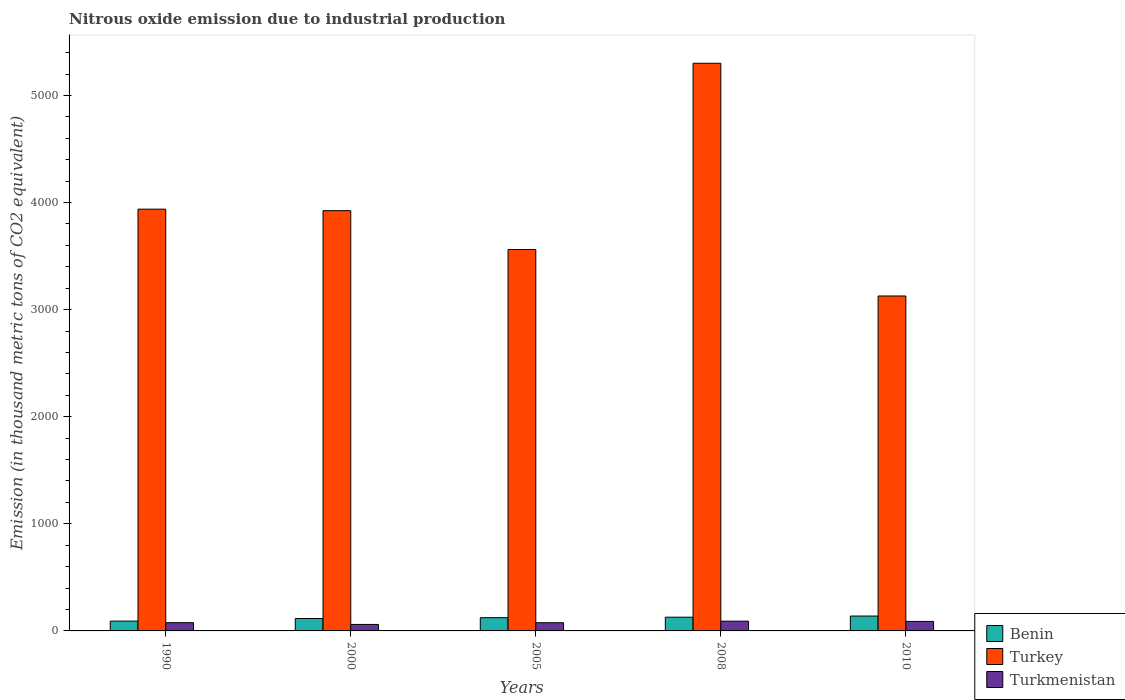How many different coloured bars are there?
Your response must be concise. 3. How many groups of bars are there?
Provide a succinct answer. 5. How many bars are there on the 5th tick from the left?
Make the answer very short. 3. How many bars are there on the 4th tick from the right?
Your answer should be compact. 3. What is the label of the 4th group of bars from the left?
Offer a terse response. 2008. What is the amount of nitrous oxide emitted in Turkey in 2008?
Give a very brief answer. 5300.3. Across all years, what is the maximum amount of nitrous oxide emitted in Benin?
Offer a very short reply. 139. Across all years, what is the minimum amount of nitrous oxide emitted in Turkmenistan?
Give a very brief answer. 60.5. What is the total amount of nitrous oxide emitted in Turkmenistan in the graph?
Your response must be concise. 393.9. What is the difference between the amount of nitrous oxide emitted in Benin in 1990 and that in 2005?
Give a very brief answer. -31.9. What is the average amount of nitrous oxide emitted in Turkmenistan per year?
Keep it short and to the point. 78.78. In the year 2008, what is the difference between the amount of nitrous oxide emitted in Benin and amount of nitrous oxide emitted in Turkmenistan?
Provide a short and direct response. 37.1. What is the ratio of the amount of nitrous oxide emitted in Benin in 2005 to that in 2008?
Offer a terse response. 0.96. Is the amount of nitrous oxide emitted in Benin in 2005 less than that in 2010?
Your answer should be very brief. Yes. What is the difference between the highest and the second highest amount of nitrous oxide emitted in Benin?
Ensure brevity in your answer.  10.8. What is the difference between the highest and the lowest amount of nitrous oxide emitted in Turkmenistan?
Your response must be concise. 30.6. In how many years, is the amount of nitrous oxide emitted in Turkey greater than the average amount of nitrous oxide emitted in Turkey taken over all years?
Your answer should be compact. 1. What does the 2nd bar from the left in 2005 represents?
Make the answer very short. Turkey. What does the 1st bar from the right in 2008 represents?
Offer a very short reply. Turkmenistan. Are all the bars in the graph horizontal?
Provide a succinct answer. No. How many years are there in the graph?
Offer a very short reply. 5. What is the difference between two consecutive major ticks on the Y-axis?
Offer a very short reply. 1000. Are the values on the major ticks of Y-axis written in scientific E-notation?
Ensure brevity in your answer.  No. Does the graph contain any zero values?
Ensure brevity in your answer.  No. Where does the legend appear in the graph?
Provide a short and direct response. Bottom right. What is the title of the graph?
Make the answer very short. Nitrous oxide emission due to industrial production. What is the label or title of the X-axis?
Provide a short and direct response. Years. What is the label or title of the Y-axis?
Your answer should be very brief. Emission (in thousand metric tons of CO2 equivalent). What is the Emission (in thousand metric tons of CO2 equivalent) in Benin in 1990?
Ensure brevity in your answer.  91.7. What is the Emission (in thousand metric tons of CO2 equivalent) in Turkey in 1990?
Provide a succinct answer. 3938.1. What is the Emission (in thousand metric tons of CO2 equivalent) in Turkmenistan in 1990?
Make the answer very short. 77.1. What is the Emission (in thousand metric tons of CO2 equivalent) of Benin in 2000?
Give a very brief answer. 115.7. What is the Emission (in thousand metric tons of CO2 equivalent) in Turkey in 2000?
Your answer should be very brief. 3923.9. What is the Emission (in thousand metric tons of CO2 equivalent) in Turkmenistan in 2000?
Ensure brevity in your answer.  60.5. What is the Emission (in thousand metric tons of CO2 equivalent) of Benin in 2005?
Your answer should be very brief. 123.6. What is the Emission (in thousand metric tons of CO2 equivalent) of Turkey in 2005?
Ensure brevity in your answer.  3561.4. What is the Emission (in thousand metric tons of CO2 equivalent) in Turkmenistan in 2005?
Provide a short and direct response. 76.5. What is the Emission (in thousand metric tons of CO2 equivalent) in Benin in 2008?
Provide a succinct answer. 128.2. What is the Emission (in thousand metric tons of CO2 equivalent) of Turkey in 2008?
Your response must be concise. 5300.3. What is the Emission (in thousand metric tons of CO2 equivalent) in Turkmenistan in 2008?
Offer a very short reply. 91.1. What is the Emission (in thousand metric tons of CO2 equivalent) in Benin in 2010?
Make the answer very short. 139. What is the Emission (in thousand metric tons of CO2 equivalent) of Turkey in 2010?
Your answer should be very brief. 3127.4. What is the Emission (in thousand metric tons of CO2 equivalent) in Turkmenistan in 2010?
Ensure brevity in your answer.  88.7. Across all years, what is the maximum Emission (in thousand metric tons of CO2 equivalent) of Benin?
Your answer should be compact. 139. Across all years, what is the maximum Emission (in thousand metric tons of CO2 equivalent) in Turkey?
Your answer should be very brief. 5300.3. Across all years, what is the maximum Emission (in thousand metric tons of CO2 equivalent) of Turkmenistan?
Keep it short and to the point. 91.1. Across all years, what is the minimum Emission (in thousand metric tons of CO2 equivalent) of Benin?
Your answer should be very brief. 91.7. Across all years, what is the minimum Emission (in thousand metric tons of CO2 equivalent) of Turkey?
Your answer should be compact. 3127.4. Across all years, what is the minimum Emission (in thousand metric tons of CO2 equivalent) in Turkmenistan?
Your response must be concise. 60.5. What is the total Emission (in thousand metric tons of CO2 equivalent) in Benin in the graph?
Provide a short and direct response. 598.2. What is the total Emission (in thousand metric tons of CO2 equivalent) in Turkey in the graph?
Keep it short and to the point. 1.99e+04. What is the total Emission (in thousand metric tons of CO2 equivalent) in Turkmenistan in the graph?
Keep it short and to the point. 393.9. What is the difference between the Emission (in thousand metric tons of CO2 equivalent) in Turkey in 1990 and that in 2000?
Give a very brief answer. 14.2. What is the difference between the Emission (in thousand metric tons of CO2 equivalent) of Turkmenistan in 1990 and that in 2000?
Your response must be concise. 16.6. What is the difference between the Emission (in thousand metric tons of CO2 equivalent) of Benin in 1990 and that in 2005?
Ensure brevity in your answer.  -31.9. What is the difference between the Emission (in thousand metric tons of CO2 equivalent) of Turkey in 1990 and that in 2005?
Ensure brevity in your answer.  376.7. What is the difference between the Emission (in thousand metric tons of CO2 equivalent) of Benin in 1990 and that in 2008?
Your answer should be very brief. -36.5. What is the difference between the Emission (in thousand metric tons of CO2 equivalent) of Turkey in 1990 and that in 2008?
Give a very brief answer. -1362.2. What is the difference between the Emission (in thousand metric tons of CO2 equivalent) of Benin in 1990 and that in 2010?
Keep it short and to the point. -47.3. What is the difference between the Emission (in thousand metric tons of CO2 equivalent) of Turkey in 1990 and that in 2010?
Offer a very short reply. 810.7. What is the difference between the Emission (in thousand metric tons of CO2 equivalent) of Turkmenistan in 1990 and that in 2010?
Your answer should be very brief. -11.6. What is the difference between the Emission (in thousand metric tons of CO2 equivalent) of Benin in 2000 and that in 2005?
Your answer should be compact. -7.9. What is the difference between the Emission (in thousand metric tons of CO2 equivalent) in Turkey in 2000 and that in 2005?
Provide a short and direct response. 362.5. What is the difference between the Emission (in thousand metric tons of CO2 equivalent) in Turkmenistan in 2000 and that in 2005?
Offer a terse response. -16. What is the difference between the Emission (in thousand metric tons of CO2 equivalent) of Benin in 2000 and that in 2008?
Your response must be concise. -12.5. What is the difference between the Emission (in thousand metric tons of CO2 equivalent) in Turkey in 2000 and that in 2008?
Provide a succinct answer. -1376.4. What is the difference between the Emission (in thousand metric tons of CO2 equivalent) in Turkmenistan in 2000 and that in 2008?
Offer a terse response. -30.6. What is the difference between the Emission (in thousand metric tons of CO2 equivalent) of Benin in 2000 and that in 2010?
Offer a terse response. -23.3. What is the difference between the Emission (in thousand metric tons of CO2 equivalent) in Turkey in 2000 and that in 2010?
Offer a terse response. 796.5. What is the difference between the Emission (in thousand metric tons of CO2 equivalent) in Turkmenistan in 2000 and that in 2010?
Ensure brevity in your answer.  -28.2. What is the difference between the Emission (in thousand metric tons of CO2 equivalent) in Turkey in 2005 and that in 2008?
Offer a terse response. -1738.9. What is the difference between the Emission (in thousand metric tons of CO2 equivalent) of Turkmenistan in 2005 and that in 2008?
Offer a very short reply. -14.6. What is the difference between the Emission (in thousand metric tons of CO2 equivalent) of Benin in 2005 and that in 2010?
Ensure brevity in your answer.  -15.4. What is the difference between the Emission (in thousand metric tons of CO2 equivalent) in Turkey in 2005 and that in 2010?
Offer a terse response. 434. What is the difference between the Emission (in thousand metric tons of CO2 equivalent) of Turkmenistan in 2005 and that in 2010?
Keep it short and to the point. -12.2. What is the difference between the Emission (in thousand metric tons of CO2 equivalent) in Turkey in 2008 and that in 2010?
Your response must be concise. 2172.9. What is the difference between the Emission (in thousand metric tons of CO2 equivalent) of Turkmenistan in 2008 and that in 2010?
Make the answer very short. 2.4. What is the difference between the Emission (in thousand metric tons of CO2 equivalent) in Benin in 1990 and the Emission (in thousand metric tons of CO2 equivalent) in Turkey in 2000?
Ensure brevity in your answer.  -3832.2. What is the difference between the Emission (in thousand metric tons of CO2 equivalent) of Benin in 1990 and the Emission (in thousand metric tons of CO2 equivalent) of Turkmenistan in 2000?
Make the answer very short. 31.2. What is the difference between the Emission (in thousand metric tons of CO2 equivalent) in Turkey in 1990 and the Emission (in thousand metric tons of CO2 equivalent) in Turkmenistan in 2000?
Your response must be concise. 3877.6. What is the difference between the Emission (in thousand metric tons of CO2 equivalent) in Benin in 1990 and the Emission (in thousand metric tons of CO2 equivalent) in Turkey in 2005?
Offer a very short reply. -3469.7. What is the difference between the Emission (in thousand metric tons of CO2 equivalent) of Turkey in 1990 and the Emission (in thousand metric tons of CO2 equivalent) of Turkmenistan in 2005?
Offer a very short reply. 3861.6. What is the difference between the Emission (in thousand metric tons of CO2 equivalent) of Benin in 1990 and the Emission (in thousand metric tons of CO2 equivalent) of Turkey in 2008?
Keep it short and to the point. -5208.6. What is the difference between the Emission (in thousand metric tons of CO2 equivalent) of Benin in 1990 and the Emission (in thousand metric tons of CO2 equivalent) of Turkmenistan in 2008?
Give a very brief answer. 0.6. What is the difference between the Emission (in thousand metric tons of CO2 equivalent) of Turkey in 1990 and the Emission (in thousand metric tons of CO2 equivalent) of Turkmenistan in 2008?
Keep it short and to the point. 3847. What is the difference between the Emission (in thousand metric tons of CO2 equivalent) of Benin in 1990 and the Emission (in thousand metric tons of CO2 equivalent) of Turkey in 2010?
Keep it short and to the point. -3035.7. What is the difference between the Emission (in thousand metric tons of CO2 equivalent) of Turkey in 1990 and the Emission (in thousand metric tons of CO2 equivalent) of Turkmenistan in 2010?
Offer a terse response. 3849.4. What is the difference between the Emission (in thousand metric tons of CO2 equivalent) of Benin in 2000 and the Emission (in thousand metric tons of CO2 equivalent) of Turkey in 2005?
Provide a short and direct response. -3445.7. What is the difference between the Emission (in thousand metric tons of CO2 equivalent) of Benin in 2000 and the Emission (in thousand metric tons of CO2 equivalent) of Turkmenistan in 2005?
Provide a succinct answer. 39.2. What is the difference between the Emission (in thousand metric tons of CO2 equivalent) in Turkey in 2000 and the Emission (in thousand metric tons of CO2 equivalent) in Turkmenistan in 2005?
Offer a terse response. 3847.4. What is the difference between the Emission (in thousand metric tons of CO2 equivalent) of Benin in 2000 and the Emission (in thousand metric tons of CO2 equivalent) of Turkey in 2008?
Provide a short and direct response. -5184.6. What is the difference between the Emission (in thousand metric tons of CO2 equivalent) in Benin in 2000 and the Emission (in thousand metric tons of CO2 equivalent) in Turkmenistan in 2008?
Provide a short and direct response. 24.6. What is the difference between the Emission (in thousand metric tons of CO2 equivalent) of Turkey in 2000 and the Emission (in thousand metric tons of CO2 equivalent) of Turkmenistan in 2008?
Offer a terse response. 3832.8. What is the difference between the Emission (in thousand metric tons of CO2 equivalent) of Benin in 2000 and the Emission (in thousand metric tons of CO2 equivalent) of Turkey in 2010?
Provide a succinct answer. -3011.7. What is the difference between the Emission (in thousand metric tons of CO2 equivalent) of Benin in 2000 and the Emission (in thousand metric tons of CO2 equivalent) of Turkmenistan in 2010?
Make the answer very short. 27. What is the difference between the Emission (in thousand metric tons of CO2 equivalent) of Turkey in 2000 and the Emission (in thousand metric tons of CO2 equivalent) of Turkmenistan in 2010?
Give a very brief answer. 3835.2. What is the difference between the Emission (in thousand metric tons of CO2 equivalent) in Benin in 2005 and the Emission (in thousand metric tons of CO2 equivalent) in Turkey in 2008?
Your answer should be very brief. -5176.7. What is the difference between the Emission (in thousand metric tons of CO2 equivalent) of Benin in 2005 and the Emission (in thousand metric tons of CO2 equivalent) of Turkmenistan in 2008?
Your answer should be very brief. 32.5. What is the difference between the Emission (in thousand metric tons of CO2 equivalent) in Turkey in 2005 and the Emission (in thousand metric tons of CO2 equivalent) in Turkmenistan in 2008?
Offer a very short reply. 3470.3. What is the difference between the Emission (in thousand metric tons of CO2 equivalent) of Benin in 2005 and the Emission (in thousand metric tons of CO2 equivalent) of Turkey in 2010?
Offer a terse response. -3003.8. What is the difference between the Emission (in thousand metric tons of CO2 equivalent) in Benin in 2005 and the Emission (in thousand metric tons of CO2 equivalent) in Turkmenistan in 2010?
Your response must be concise. 34.9. What is the difference between the Emission (in thousand metric tons of CO2 equivalent) in Turkey in 2005 and the Emission (in thousand metric tons of CO2 equivalent) in Turkmenistan in 2010?
Your answer should be compact. 3472.7. What is the difference between the Emission (in thousand metric tons of CO2 equivalent) in Benin in 2008 and the Emission (in thousand metric tons of CO2 equivalent) in Turkey in 2010?
Your response must be concise. -2999.2. What is the difference between the Emission (in thousand metric tons of CO2 equivalent) of Benin in 2008 and the Emission (in thousand metric tons of CO2 equivalent) of Turkmenistan in 2010?
Give a very brief answer. 39.5. What is the difference between the Emission (in thousand metric tons of CO2 equivalent) of Turkey in 2008 and the Emission (in thousand metric tons of CO2 equivalent) of Turkmenistan in 2010?
Provide a short and direct response. 5211.6. What is the average Emission (in thousand metric tons of CO2 equivalent) in Benin per year?
Make the answer very short. 119.64. What is the average Emission (in thousand metric tons of CO2 equivalent) in Turkey per year?
Ensure brevity in your answer.  3970.22. What is the average Emission (in thousand metric tons of CO2 equivalent) in Turkmenistan per year?
Your answer should be very brief. 78.78. In the year 1990, what is the difference between the Emission (in thousand metric tons of CO2 equivalent) of Benin and Emission (in thousand metric tons of CO2 equivalent) of Turkey?
Make the answer very short. -3846.4. In the year 1990, what is the difference between the Emission (in thousand metric tons of CO2 equivalent) of Benin and Emission (in thousand metric tons of CO2 equivalent) of Turkmenistan?
Provide a succinct answer. 14.6. In the year 1990, what is the difference between the Emission (in thousand metric tons of CO2 equivalent) in Turkey and Emission (in thousand metric tons of CO2 equivalent) in Turkmenistan?
Your answer should be very brief. 3861. In the year 2000, what is the difference between the Emission (in thousand metric tons of CO2 equivalent) of Benin and Emission (in thousand metric tons of CO2 equivalent) of Turkey?
Your response must be concise. -3808.2. In the year 2000, what is the difference between the Emission (in thousand metric tons of CO2 equivalent) in Benin and Emission (in thousand metric tons of CO2 equivalent) in Turkmenistan?
Make the answer very short. 55.2. In the year 2000, what is the difference between the Emission (in thousand metric tons of CO2 equivalent) in Turkey and Emission (in thousand metric tons of CO2 equivalent) in Turkmenistan?
Keep it short and to the point. 3863.4. In the year 2005, what is the difference between the Emission (in thousand metric tons of CO2 equivalent) in Benin and Emission (in thousand metric tons of CO2 equivalent) in Turkey?
Your answer should be very brief. -3437.8. In the year 2005, what is the difference between the Emission (in thousand metric tons of CO2 equivalent) in Benin and Emission (in thousand metric tons of CO2 equivalent) in Turkmenistan?
Provide a succinct answer. 47.1. In the year 2005, what is the difference between the Emission (in thousand metric tons of CO2 equivalent) in Turkey and Emission (in thousand metric tons of CO2 equivalent) in Turkmenistan?
Offer a terse response. 3484.9. In the year 2008, what is the difference between the Emission (in thousand metric tons of CO2 equivalent) in Benin and Emission (in thousand metric tons of CO2 equivalent) in Turkey?
Make the answer very short. -5172.1. In the year 2008, what is the difference between the Emission (in thousand metric tons of CO2 equivalent) in Benin and Emission (in thousand metric tons of CO2 equivalent) in Turkmenistan?
Your answer should be compact. 37.1. In the year 2008, what is the difference between the Emission (in thousand metric tons of CO2 equivalent) in Turkey and Emission (in thousand metric tons of CO2 equivalent) in Turkmenistan?
Offer a terse response. 5209.2. In the year 2010, what is the difference between the Emission (in thousand metric tons of CO2 equivalent) of Benin and Emission (in thousand metric tons of CO2 equivalent) of Turkey?
Ensure brevity in your answer.  -2988.4. In the year 2010, what is the difference between the Emission (in thousand metric tons of CO2 equivalent) in Benin and Emission (in thousand metric tons of CO2 equivalent) in Turkmenistan?
Your answer should be compact. 50.3. In the year 2010, what is the difference between the Emission (in thousand metric tons of CO2 equivalent) of Turkey and Emission (in thousand metric tons of CO2 equivalent) of Turkmenistan?
Your answer should be compact. 3038.7. What is the ratio of the Emission (in thousand metric tons of CO2 equivalent) of Benin in 1990 to that in 2000?
Your answer should be compact. 0.79. What is the ratio of the Emission (in thousand metric tons of CO2 equivalent) in Turkey in 1990 to that in 2000?
Make the answer very short. 1. What is the ratio of the Emission (in thousand metric tons of CO2 equivalent) in Turkmenistan in 1990 to that in 2000?
Your answer should be very brief. 1.27. What is the ratio of the Emission (in thousand metric tons of CO2 equivalent) in Benin in 1990 to that in 2005?
Your answer should be very brief. 0.74. What is the ratio of the Emission (in thousand metric tons of CO2 equivalent) of Turkey in 1990 to that in 2005?
Make the answer very short. 1.11. What is the ratio of the Emission (in thousand metric tons of CO2 equivalent) of Benin in 1990 to that in 2008?
Provide a succinct answer. 0.72. What is the ratio of the Emission (in thousand metric tons of CO2 equivalent) of Turkey in 1990 to that in 2008?
Your response must be concise. 0.74. What is the ratio of the Emission (in thousand metric tons of CO2 equivalent) in Turkmenistan in 1990 to that in 2008?
Keep it short and to the point. 0.85. What is the ratio of the Emission (in thousand metric tons of CO2 equivalent) of Benin in 1990 to that in 2010?
Provide a short and direct response. 0.66. What is the ratio of the Emission (in thousand metric tons of CO2 equivalent) in Turkey in 1990 to that in 2010?
Ensure brevity in your answer.  1.26. What is the ratio of the Emission (in thousand metric tons of CO2 equivalent) of Turkmenistan in 1990 to that in 2010?
Ensure brevity in your answer.  0.87. What is the ratio of the Emission (in thousand metric tons of CO2 equivalent) in Benin in 2000 to that in 2005?
Ensure brevity in your answer.  0.94. What is the ratio of the Emission (in thousand metric tons of CO2 equivalent) in Turkey in 2000 to that in 2005?
Your answer should be very brief. 1.1. What is the ratio of the Emission (in thousand metric tons of CO2 equivalent) in Turkmenistan in 2000 to that in 2005?
Your answer should be very brief. 0.79. What is the ratio of the Emission (in thousand metric tons of CO2 equivalent) in Benin in 2000 to that in 2008?
Give a very brief answer. 0.9. What is the ratio of the Emission (in thousand metric tons of CO2 equivalent) in Turkey in 2000 to that in 2008?
Make the answer very short. 0.74. What is the ratio of the Emission (in thousand metric tons of CO2 equivalent) in Turkmenistan in 2000 to that in 2008?
Give a very brief answer. 0.66. What is the ratio of the Emission (in thousand metric tons of CO2 equivalent) in Benin in 2000 to that in 2010?
Your response must be concise. 0.83. What is the ratio of the Emission (in thousand metric tons of CO2 equivalent) in Turkey in 2000 to that in 2010?
Ensure brevity in your answer.  1.25. What is the ratio of the Emission (in thousand metric tons of CO2 equivalent) in Turkmenistan in 2000 to that in 2010?
Provide a short and direct response. 0.68. What is the ratio of the Emission (in thousand metric tons of CO2 equivalent) of Benin in 2005 to that in 2008?
Provide a succinct answer. 0.96. What is the ratio of the Emission (in thousand metric tons of CO2 equivalent) in Turkey in 2005 to that in 2008?
Your answer should be compact. 0.67. What is the ratio of the Emission (in thousand metric tons of CO2 equivalent) of Turkmenistan in 2005 to that in 2008?
Your response must be concise. 0.84. What is the ratio of the Emission (in thousand metric tons of CO2 equivalent) of Benin in 2005 to that in 2010?
Make the answer very short. 0.89. What is the ratio of the Emission (in thousand metric tons of CO2 equivalent) of Turkey in 2005 to that in 2010?
Your answer should be very brief. 1.14. What is the ratio of the Emission (in thousand metric tons of CO2 equivalent) of Turkmenistan in 2005 to that in 2010?
Your answer should be compact. 0.86. What is the ratio of the Emission (in thousand metric tons of CO2 equivalent) in Benin in 2008 to that in 2010?
Make the answer very short. 0.92. What is the ratio of the Emission (in thousand metric tons of CO2 equivalent) in Turkey in 2008 to that in 2010?
Your response must be concise. 1.69. What is the ratio of the Emission (in thousand metric tons of CO2 equivalent) of Turkmenistan in 2008 to that in 2010?
Ensure brevity in your answer.  1.03. What is the difference between the highest and the second highest Emission (in thousand metric tons of CO2 equivalent) in Benin?
Your response must be concise. 10.8. What is the difference between the highest and the second highest Emission (in thousand metric tons of CO2 equivalent) in Turkey?
Provide a short and direct response. 1362.2. What is the difference between the highest and the lowest Emission (in thousand metric tons of CO2 equivalent) of Benin?
Provide a short and direct response. 47.3. What is the difference between the highest and the lowest Emission (in thousand metric tons of CO2 equivalent) in Turkey?
Make the answer very short. 2172.9. What is the difference between the highest and the lowest Emission (in thousand metric tons of CO2 equivalent) in Turkmenistan?
Ensure brevity in your answer.  30.6. 